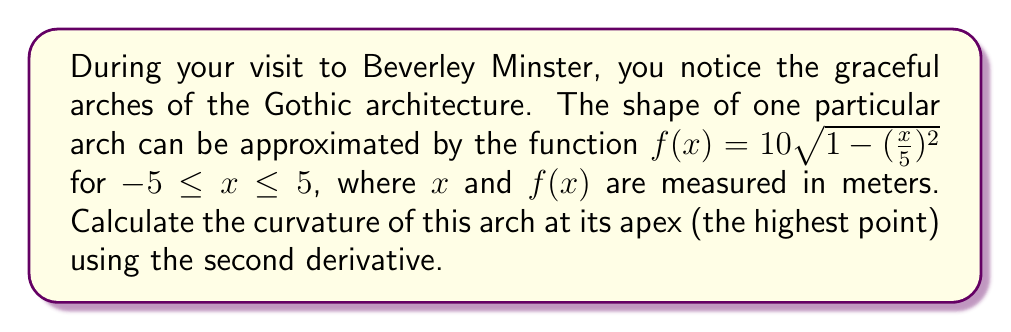Can you solve this math problem? To find the curvature at the apex of the arch, we'll follow these steps:

1) The formula for curvature is:

   $\kappa = \frac{|f''(x)|}{(1+[f'(x)]^2)^{3/2}}$

2) First, let's find $f'(x)$:
   
   $f'(x) = 10 \cdot \frac{1}{2\sqrt{1-(\frac{x}{5})^2}} \cdot (-2)(\frac{x}{5})(\frac{1}{5})$
   
   $f'(x) = -\frac{x}{5\sqrt{25-x^2}}$

3) Now, let's find $f''(x)$:
   
   $f''(x) = -\frac{1}{5\sqrt{25-x^2}} + \frac{x^2}{5(25-x^2)^{3/2}}$

4) The apex of the arch is at $x=0$. Let's evaluate $f'(0)$ and $f''(0)$:

   $f'(0) = 0$
   
   $f''(0) = -\frac{1}{5\sqrt{25}} = -\frac{1}{25}$

5) Now we can substitute these values into the curvature formula:

   $\kappa = \frac{|-\frac{1}{25}|}{(1+0^2)^{3/2}} = \frac{1}{25}$

Therefore, the curvature at the apex of the arch is $\frac{1}{25}$ m^(-1).
Answer: $\frac{1}{25}$ m^(-1) 